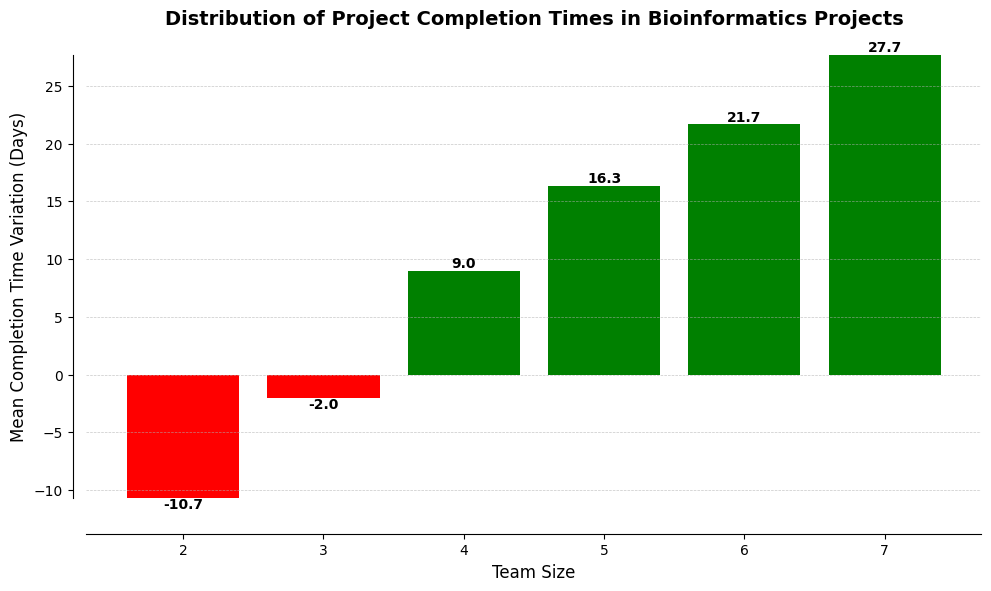What is the mean completion time variation for teams with 2 members? The bar representing teams with 2 members shows a negative mean value of approximately -10.7 days.
Answer: -10.7 days Which team size has the highest positive mean completion time variation? The tallest green bar corresponds to the 7-member team, indicating the highest positive mean completion time variation.
Answer: 7-member team How does the mean completion time variation change as the team size increases from 2 to 6? The completion time variation starts from approximately -10.7 for 2-member teams, becomes positive at 3 members reaching around -2, and continues to increase positively up to around 22.5 for 6-member teams.
Answer: Increases from -10.7 to 22.5 What is the difference in mean completion time variation between teams with 4 and 5 members? The bar for 4-member teams shows a mean variation of approximately 9 days, while the bar for 5-member teams shows around 16.3 days. The difference is calculated as 16.3 - 9.0 = 7.3 days.
Answer: 7.3 days Which team size has the greatest negative mean completion time variation? The shortest red bar corresponds to the 2-member team, indicating the greatest negative mean completion time variation.
Answer: 2-member team What is the range of mean completion time variations for all team sizes? The lowest value is approximately -10.7 (for 2-member teams) and the highest value is around 27.7 (for 7-member teams). The range is 27.7 - (-10.7) = 38.4 days.
Answer: 38.4 days Which team size marks the transition from negative to positive mean completion time variations? Teams with a size of 3 have a mean variation slightly positive, indicating a transition from negative (teams with 2 members) to positive mean completion time variations.
Answer: 3-member team Compare the mean completion time variations between the smallest team size and the largest team size. The smallest team size (2 members) has a mean completion time variation of approximately -10.7 days, while the largest team size (7 members) has around 27.7 days. The comparison shows a significant increase (27.7 - (-10.7)) = 38.4 days.
Answer: -10.7 days vs 27.7 days Which team sizes have only positive mean completion time variations? Observing the green bars, team sizes 4, 5, 6, and 7 have only positive mean completion time variations.
Answer: 4, 5, 6, 7-member teams 